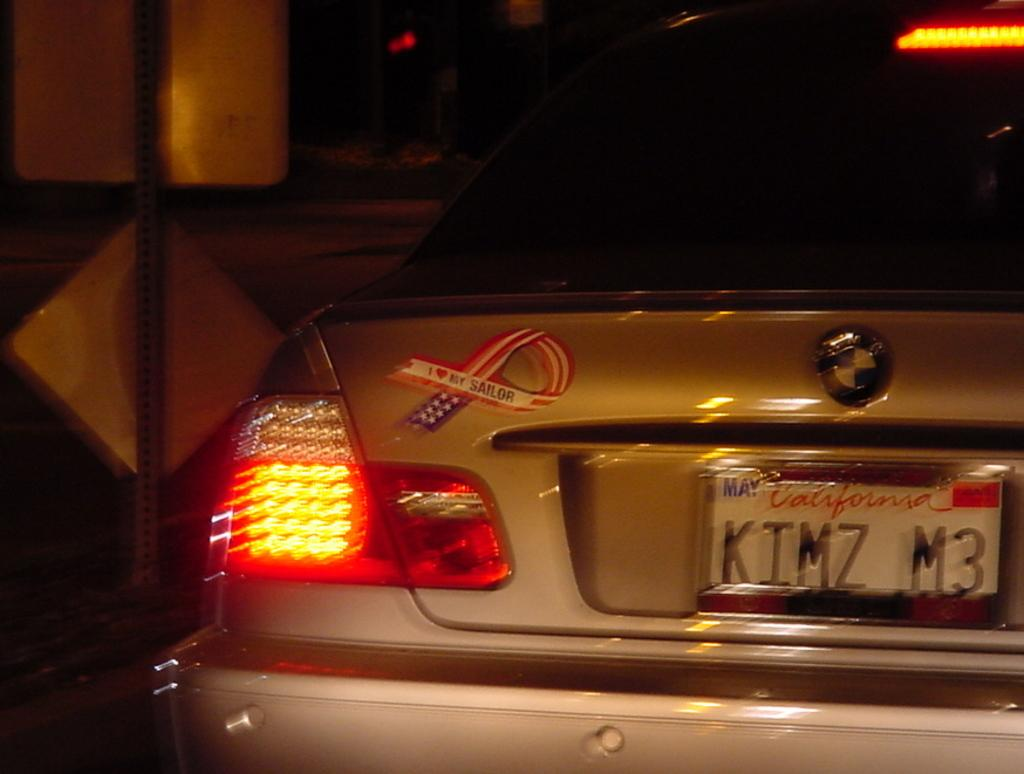<image>
Describe the image concisely. California license plate on a car that says KIMZ M3. 